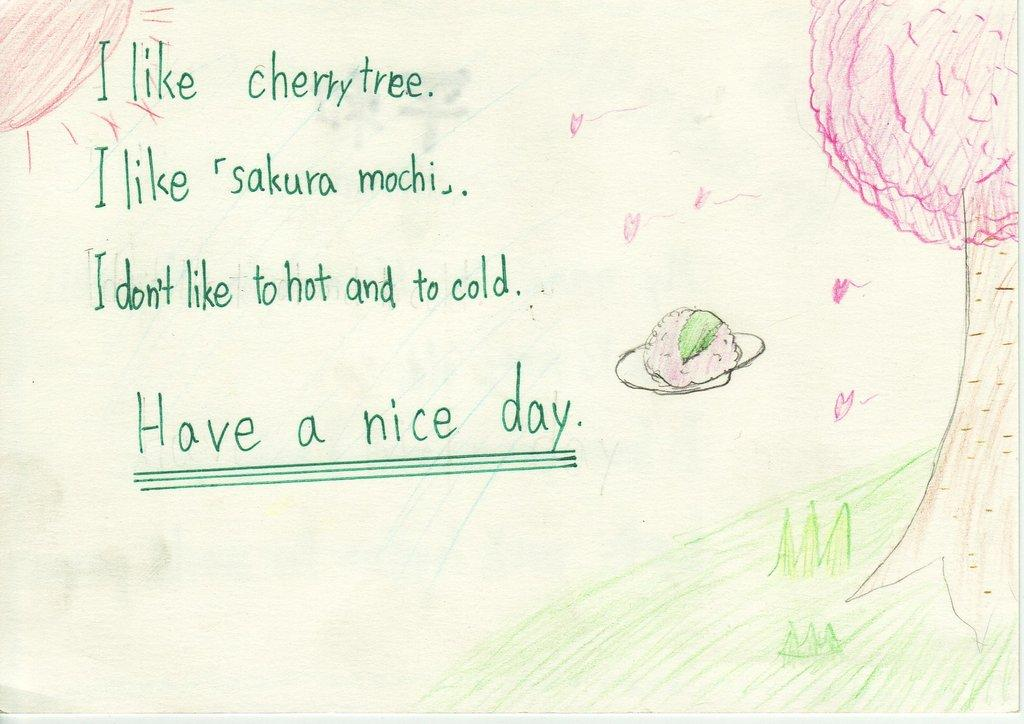What type of natural elements are depicted in the image? There is a drawing of grass and a tree in the image. Are there any other drawings in the image besides the grass and tree? Yes, there are other drawings in the image. What else can be found in the image besides drawings? There is text written in the image. What is the temper of the tree in the image? The image does not depict the temper of the tree, as it is a drawing and not a living organism. 